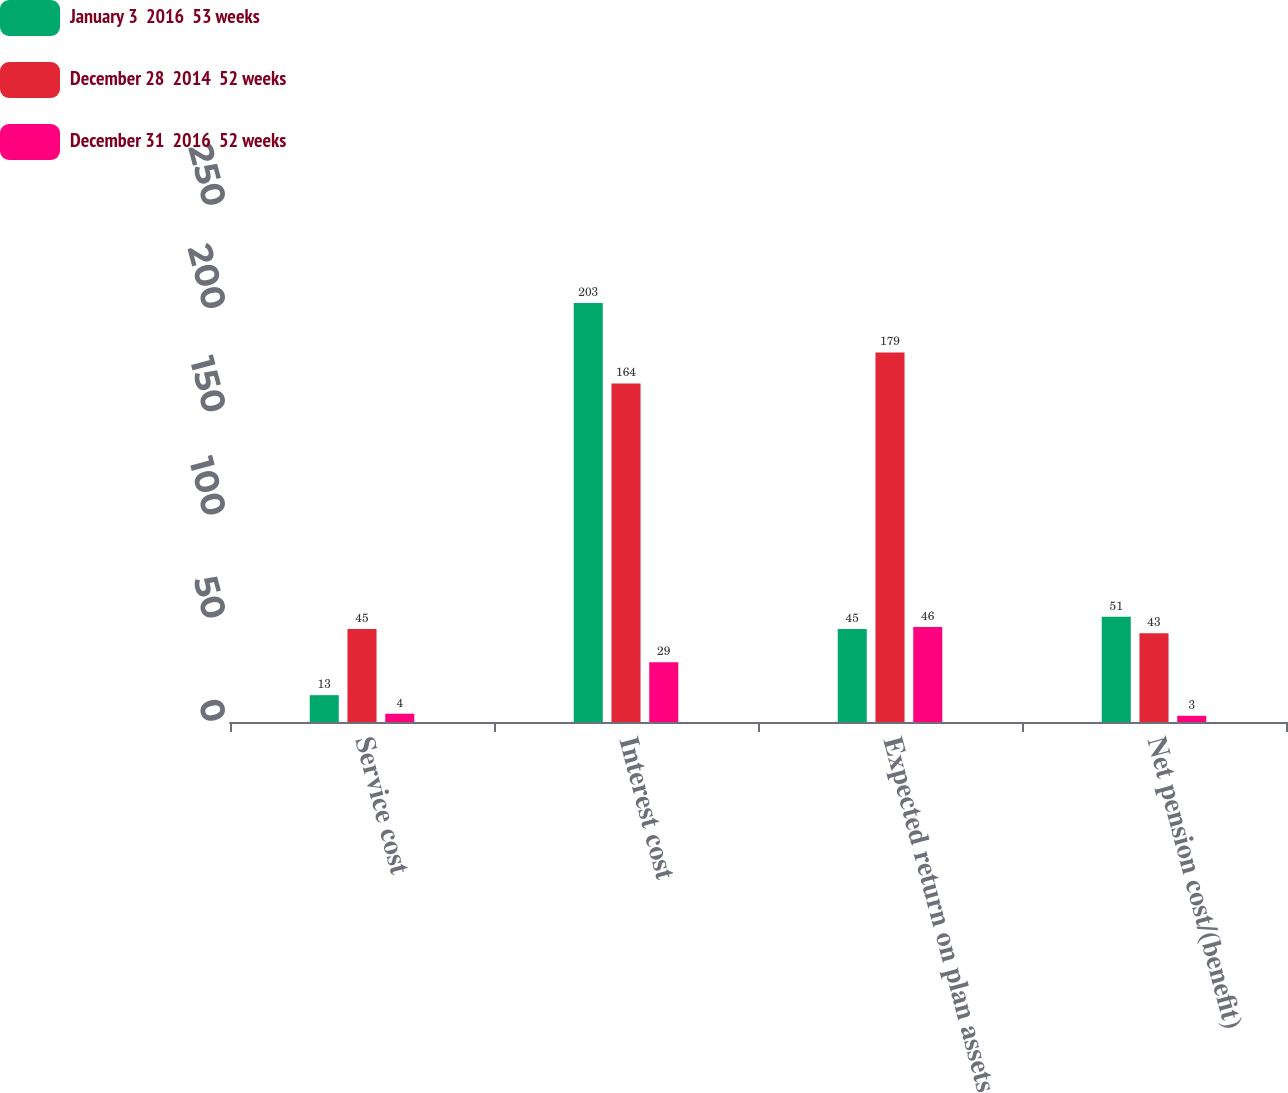<chart> <loc_0><loc_0><loc_500><loc_500><stacked_bar_chart><ecel><fcel>Service cost<fcel>Interest cost<fcel>Expected return on plan assets<fcel>Net pension cost/(benefit)<nl><fcel>January 3  2016  53 weeks<fcel>13<fcel>203<fcel>45<fcel>51<nl><fcel>December 28  2014  52 weeks<fcel>45<fcel>164<fcel>179<fcel>43<nl><fcel>December 31  2016  52 weeks<fcel>4<fcel>29<fcel>46<fcel>3<nl></chart> 